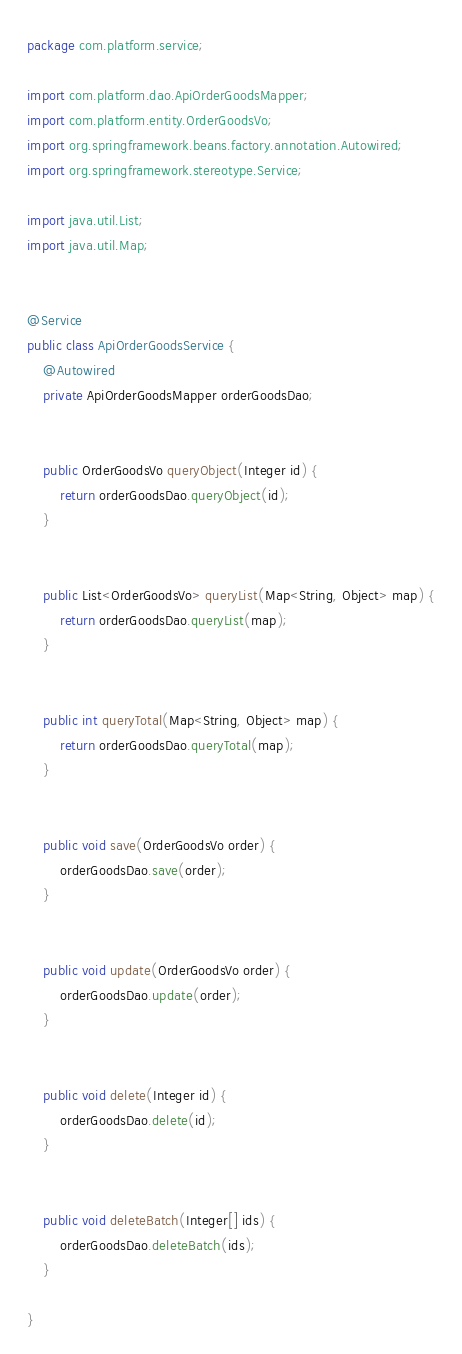<code> <loc_0><loc_0><loc_500><loc_500><_Java_>package com.platform.service;

import com.platform.dao.ApiOrderGoodsMapper;
import com.platform.entity.OrderGoodsVo;
import org.springframework.beans.factory.annotation.Autowired;
import org.springframework.stereotype.Service;

import java.util.List;
import java.util.Map;


@Service
public class ApiOrderGoodsService {
    @Autowired
    private ApiOrderGoodsMapper orderGoodsDao;


    public OrderGoodsVo queryObject(Integer id) {
        return orderGoodsDao.queryObject(id);
    }


    public List<OrderGoodsVo> queryList(Map<String, Object> map) {
        return orderGoodsDao.queryList(map);
    }


    public int queryTotal(Map<String, Object> map) {
        return orderGoodsDao.queryTotal(map);
    }


    public void save(OrderGoodsVo order) {
        orderGoodsDao.save(order);
    }


    public void update(OrderGoodsVo order) {
        orderGoodsDao.update(order);
    }


    public void delete(Integer id) {
        orderGoodsDao.delete(id);
    }


    public void deleteBatch(Integer[] ids) {
        orderGoodsDao.deleteBatch(ids);
    }

}</code> 